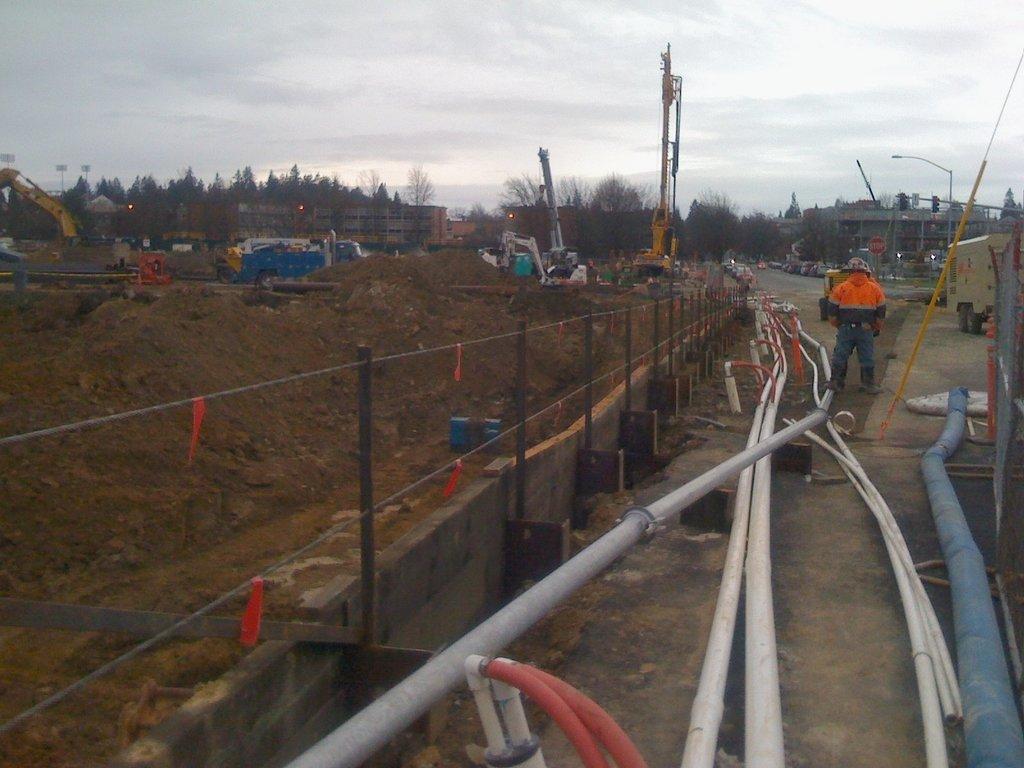How would you summarize this image in a sentence or two? In this image at front there are pipes. At the left side of the image there is sand. At the back side there are cranes. At the background there are buildings, trees and sky. At the center of the image there is a person standing on the road. 